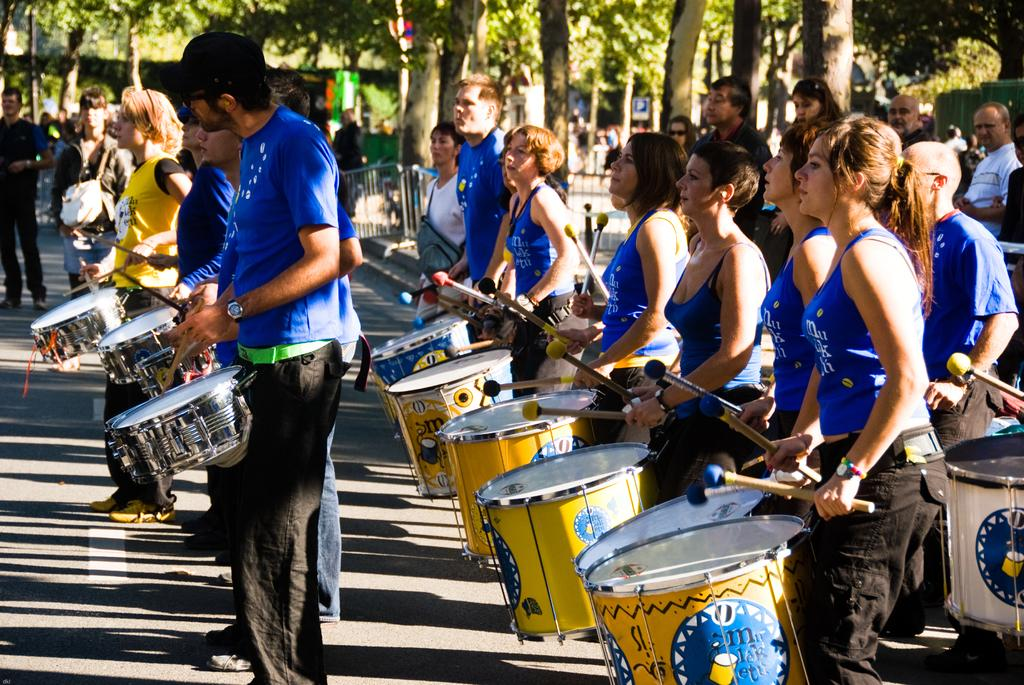What are the musicians in the image doing? The musicians in the image are playing drums. What can be seen in the background of the image? There are trees and people in the background of the image. Can you describe the appearance of the man on the left side of the image? The man on the left side of the image is wearing a black dress. What type of brain is visible in the image? There is no brain present in the image. Can you describe the wheel used by the musicians in the image? There are no wheels present in the image; the musicians are playing drums. 